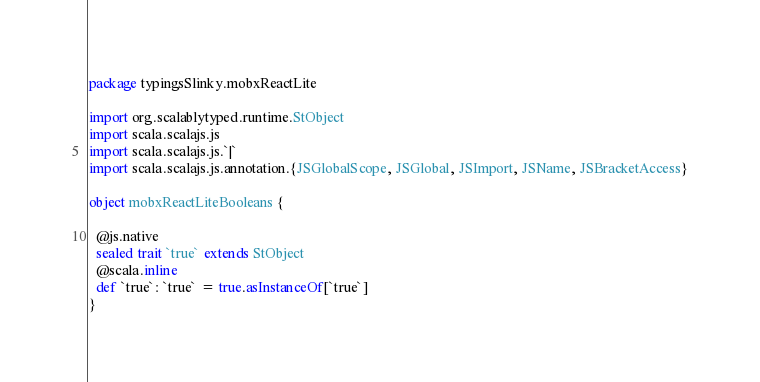Convert code to text. <code><loc_0><loc_0><loc_500><loc_500><_Scala_>package typingsSlinky.mobxReactLite

import org.scalablytyped.runtime.StObject
import scala.scalajs.js
import scala.scalajs.js.`|`
import scala.scalajs.js.annotation.{JSGlobalScope, JSGlobal, JSImport, JSName, JSBracketAccess}

object mobxReactLiteBooleans {
  
  @js.native
  sealed trait `true` extends StObject
  @scala.inline
  def `true`: `true` = true.asInstanceOf[`true`]
}
</code> 